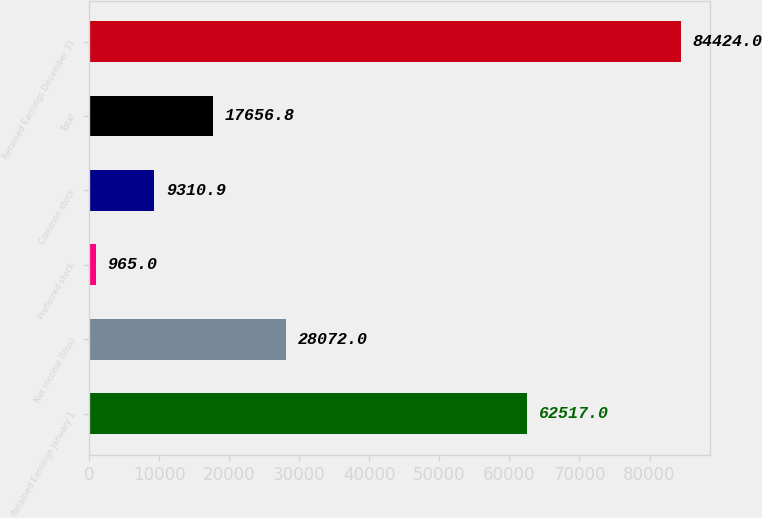Convert chart. <chart><loc_0><loc_0><loc_500><loc_500><bar_chart><fcel>Retained Earnings January 1<fcel>Net income (loss)<fcel>Preferred stock<fcel>Common stock<fcel>Total<fcel>Retained Earnings December 31<nl><fcel>62517<fcel>28072<fcel>965<fcel>9310.9<fcel>17656.8<fcel>84424<nl></chart> 